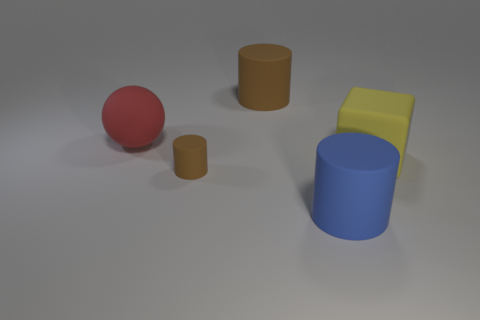There is a object that is left of the blue thing and right of the tiny rubber thing; what shape is it?
Ensure brevity in your answer.  Cylinder. What material is the large cylinder that is in front of the brown rubber object that is left of the big rubber object that is behind the large red object made of?
Your response must be concise. Rubber. Are there more red rubber spheres that are in front of the big brown cylinder than red matte things on the right side of the cube?
Ensure brevity in your answer.  Yes. What number of objects have the same material as the large block?
Keep it short and to the point. 4. There is a large matte thing right of the large blue rubber cylinder; is its shape the same as the brown rubber thing in front of the large brown rubber thing?
Provide a succinct answer. No. There is a cylinder that is in front of the small rubber thing; what is its color?
Provide a short and direct response. Blue. Are there any green rubber things that have the same shape as the tiny brown matte object?
Give a very brief answer. No. What is the material of the ball?
Make the answer very short. Rubber. There is a cylinder that is both to the left of the big blue matte cylinder and right of the small brown object; what is its size?
Provide a short and direct response. Large. There is a large cylinder that is the same color as the small rubber object; what is it made of?
Make the answer very short. Rubber. 